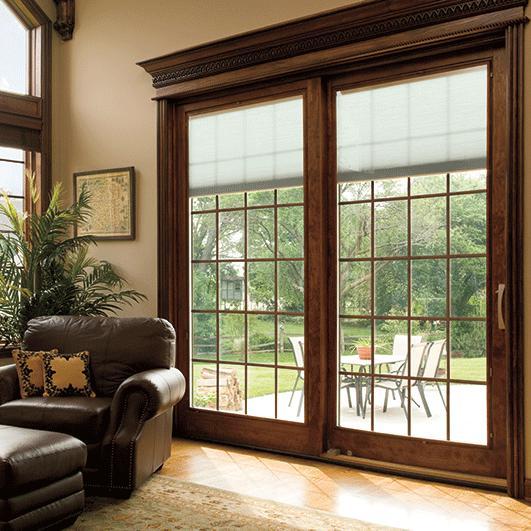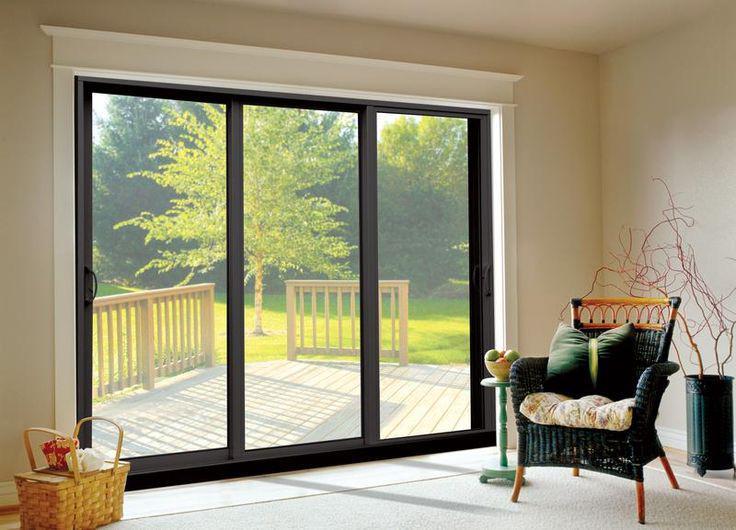The first image is the image on the left, the second image is the image on the right. For the images shown, is this caption "There is only one chair near the door in the right image." true? Answer yes or no. Yes. 